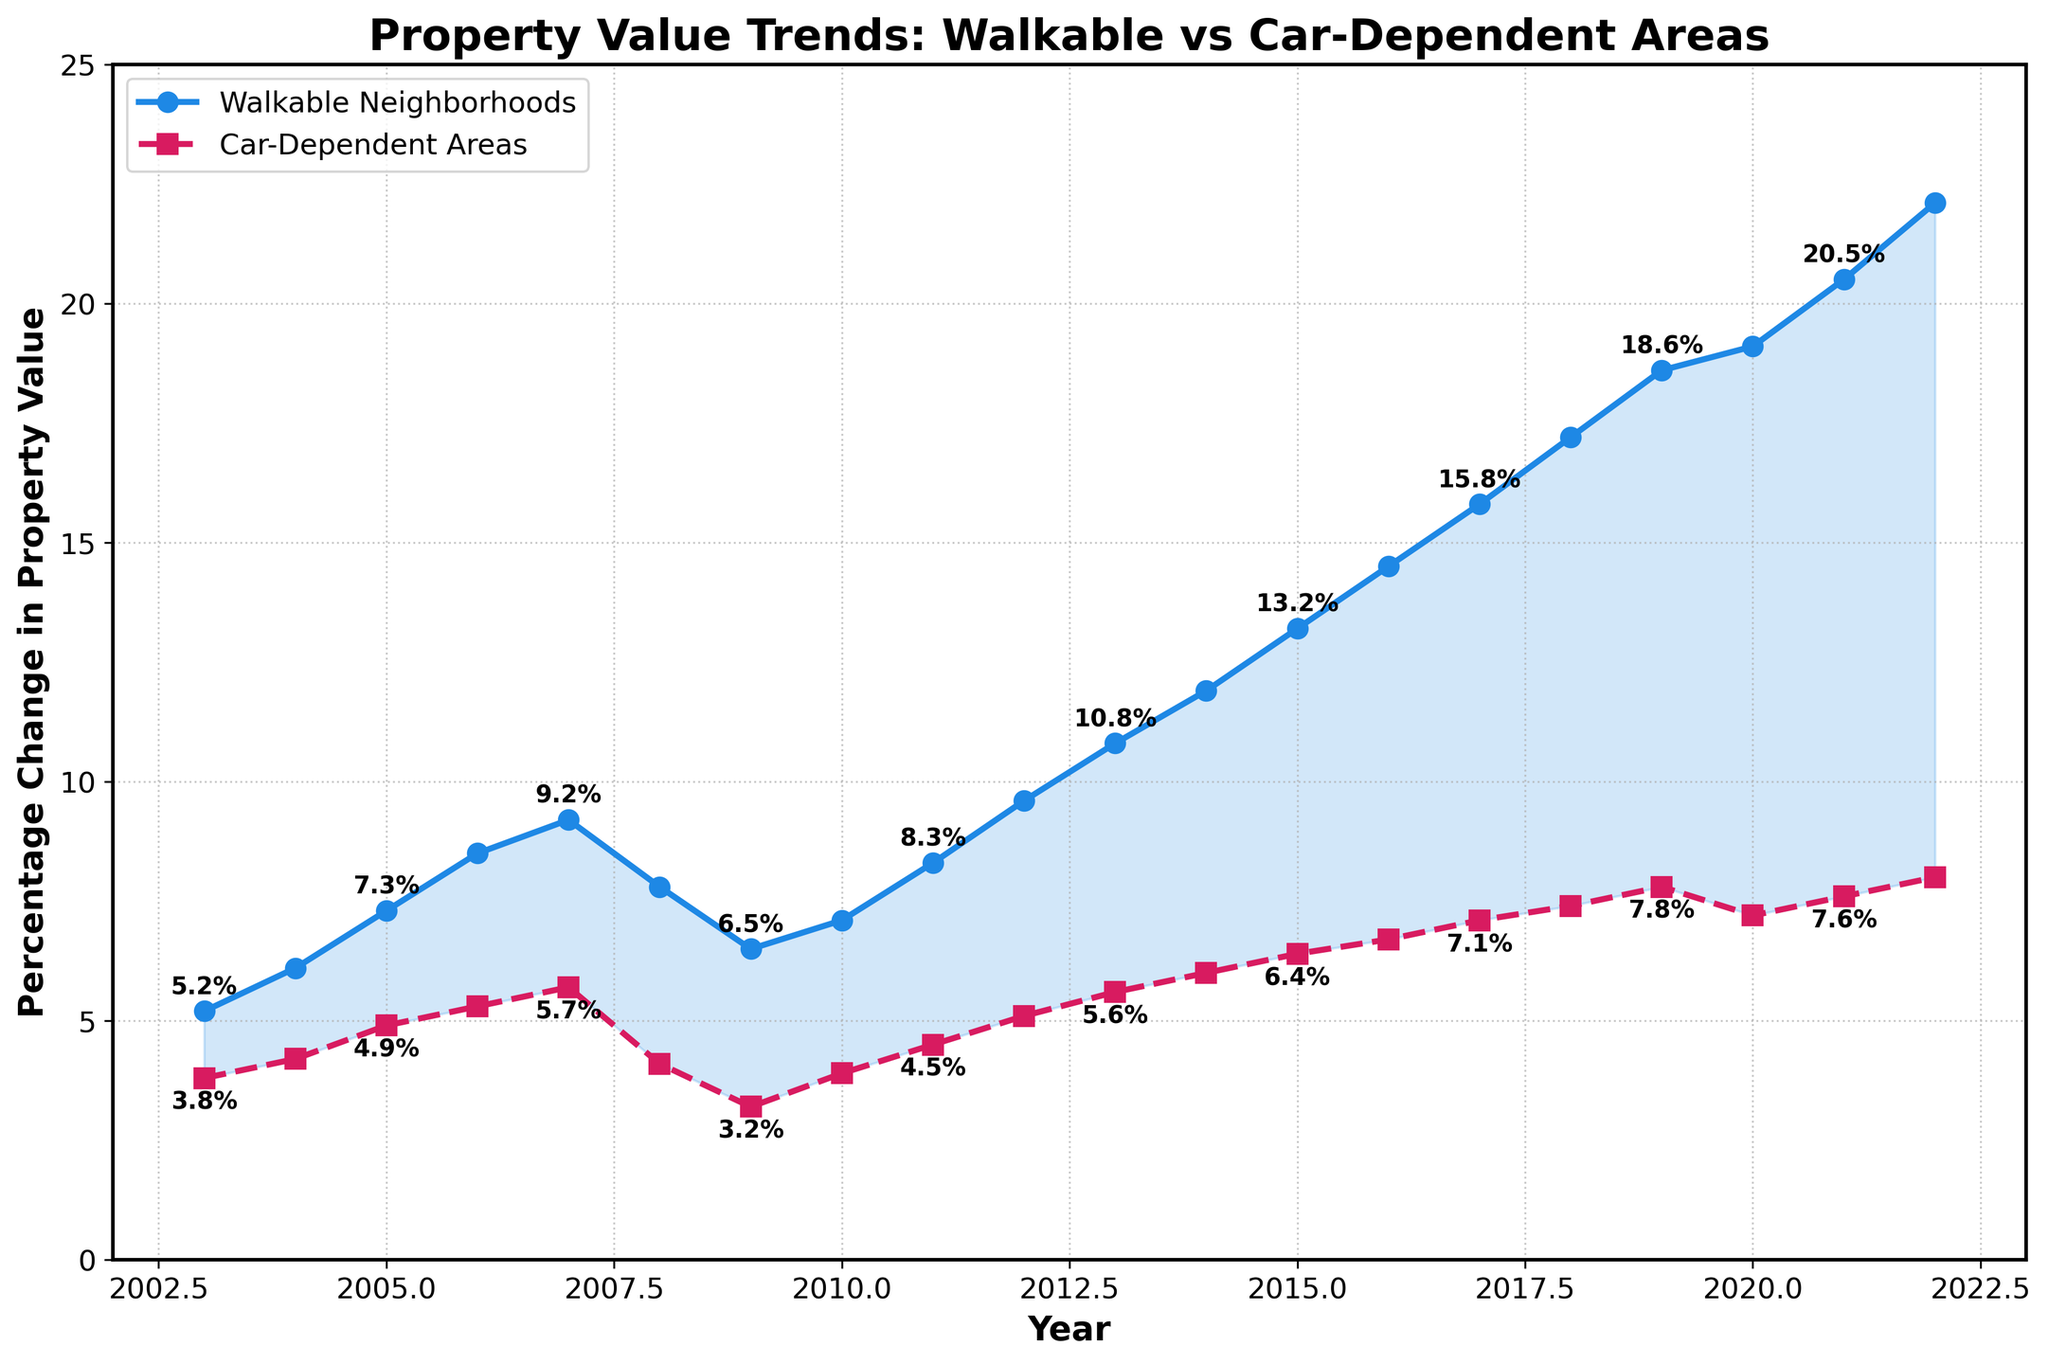Which area shows a higher percentage change in property value in 2007? The line for "Walkable Neighborhoods" is higher than that for "Car-Dependent Areas" in 2007. The respective values are 9.2% and 5.7%.
Answer: Walkable Neighborhoods What is the average percentage change in property values for Walkable Neighborhoods between 2018 and 2022? The percentage changes are 17.2%, 18.6%, 19.1%, 20.5%, and 22.1%. Summing these values gives 97.5%, and the average is 97.5/5 = 19.5%.
Answer: 19.5% In which year do Walkable Neighborhoods see the greatest percentage increase compared to the previous year? The largest increase occurs between 2011 and 2012, from 8.3% to 9.6%, a 1.3% increase.
Answer: 2012 How does the percentage change for Car-Dependent Areas in 2018 compare to its percentage change in 2008? In 2018, the change is 7.4%, and in 2008, it is 4.1%. The change in 2018 is greater.
Answer: Greater in 2018 Are there any years where the percentage change in property values for Walkable Neighborhoods decreased? If yes, specify the years. Observing the trend line for Walkable Neighborhoods, there are no years where the percentage change shows a decrease.
Answer: No What is the difference in percentage change between Walkable Neighborhoods and Car-Dependent Areas in 2022? The percentage change for Walkable Neighborhoods in 2022 is 22.1%, and for Car-Dependent Areas, it is 8.0%. The difference is 22.1% - 8.0% = 14.1%.
Answer: 14.1% Which data points are annotated on the chart for Walkable Neighborhoods? Annotations for Walkable Neighborhoods are present for the years 2003, 2005, 2007, 2009, 2011, 2013, 2015, 2017, 2019, and 2021.
Answer: 2003, 2005, 2007, 2009, 2011, 2013, 2015, 2017, 2019, 2021 What is the trend observed in the percentage change in property values for Car-Dependent Areas from 2003 to 2022? The line for Car-Dependent Areas shows a generally increasing trend from 3.8% in 2003 to 8.0% in 2022.
Answer: Increasing In which year is the gap between Walkable Neighborhoods and Car-Dependent Areas percentage changes the smallest? The difference is smallest in 2009. The respective values are 6.5% for Walkable Neighborhoods and 3.2% for Car-Dependent Areas, giving a difference of 3.3%.
Answer: 2009 